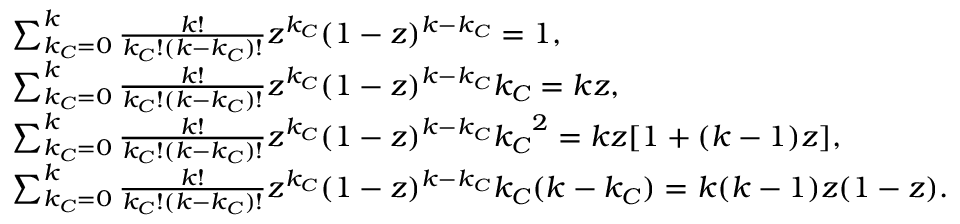<formula> <loc_0><loc_0><loc_500><loc_500>\begin{array} { r l } & { \sum _ { k _ { C } = 0 } ^ { k } { \frac { k ! } { k _ { C } ! ( k - k _ { C } ) ! } z ^ { k _ { C } } ( 1 - z ) ^ { k - k _ { C } } } = 1 , } \\ & { \sum _ { k _ { C } = 0 } ^ { k } { \frac { k ! } { k _ { C } ! ( k - k _ { C } ) ! } z ^ { k _ { C } } ( 1 - z ) ^ { k - k _ { C } } k _ { C } } = k z , } \\ & { \sum _ { k _ { C } = 0 } ^ { k } { \frac { k ! } { k _ { C } ! ( k - k _ { C } ) ! } z ^ { k _ { C } } ( 1 - z ) ^ { k - k _ { C } } { k _ { C } } ^ { 2 } } = k z [ 1 + ( k - 1 ) z ] , } \\ & { \sum _ { k _ { C } = 0 } ^ { k } { \frac { k ! } { k _ { C } ! ( k - k _ { C } ) ! } z ^ { k _ { C } } ( 1 - z ) ^ { k - k _ { C } } k _ { C } ( k - k _ { C } ) } = k ( k - 1 ) z ( 1 - z ) . } \end{array}</formula> 